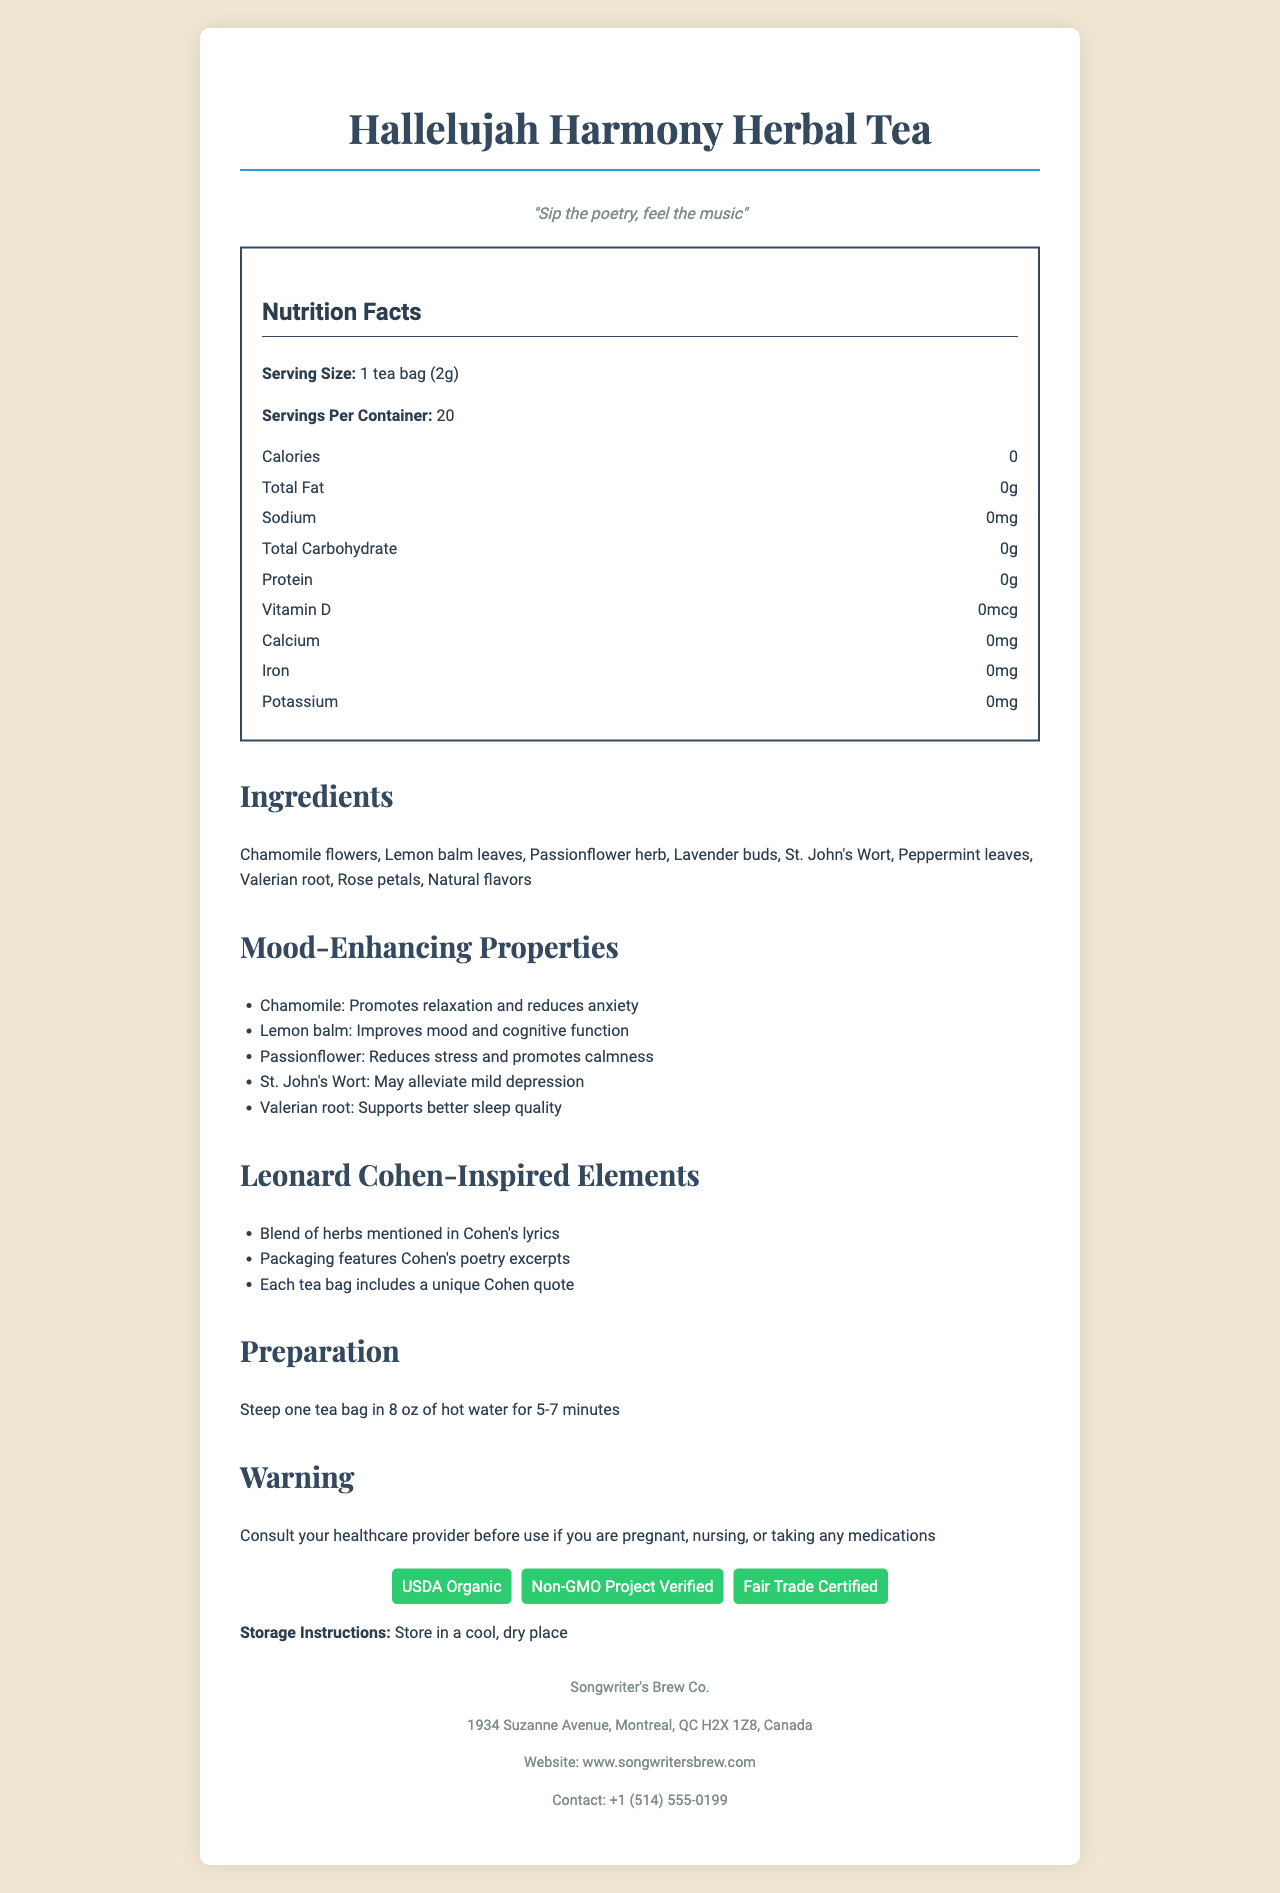What is the serving size of Hallelujah Harmony Herbal Tea? The serving size is explicitly stated as 1 tea bag (2g) in the document.
Answer: 1 tea bag (2g) How many servings are in one container of this herbal tea? The document clearly mentions that there are 20 servings per container.
Answer: 20 What are the mood-enhancing properties of St. John's Wort listed in the document? The document specifies that St. John's Wort may alleviate mild depression.
Answer: May alleviate mild depression Which ingredient in the tea promotes relaxation and reduces anxiety? Chamomile is mentioned under mood-enhancing properties as promoting relaxation and reducing anxiety.
Answer: Chamomile Is this product made with organic ingredients? The certifications section lists USDA Organic, indicating that the product is made with organic ingredients.
Answer: Yes How long should you steep the tea for optimal flavor? A. 2-4 minutes B. 5-7 minutes C. 8-10 minutes D. 10-12 minutes The preparation instructions recommend steeping one tea bag in 8 oz of hot water for 5-7 minutes.
Answer: B. 5-7 minutes Which of the following is NOT an ingredient in the Hallelujah Harmony Herbal Tea? A. Chamomile B. Ginger C. Rose petals D. Valerian root The ingredients list does not include ginger.
Answer: B. Ginger Is the tea manufactured in a facility that processes almonds? The allergen information states that the tea is manufactured in a facility that processes tree nuts, which includes almonds.
Answer: Yes Summarize the overall theme and unique aspects of the Hallelujah Harmony Herbal Tea document. The document combines nutritional facts, ingredients, mood-enhancing properties, and Leonard Cohen-inspired elements. It highlights the organic nature of the tea, manufacturing details, and certifications while providing a preparation guide and allergen information.
Answer: The Hallelujah Harmony Herbal Tea is a Leonard Cohen-inspired herbal blend with mood-enhancing properties. It includes several organic herbs like Chamomile, Lemon balm, and Valerian root, each with specific calming and stress-relieving benefits. The product is manufactured by Songwriter's Brew Co. and features unique Leonard Cohen-inspired elements such as poetry excerpts on the packaging and quotes with each tea bag. Nutrition facts show zero calories, fat, sodium, carbohydrates, and protein per serving. The tea is also certified USDA Organic, Non-GMO Project Verified, and Fair Trade Certified. Does the document mention where you can buy the tea? The document provides the company’s website and contact information but does not explicitly mention where the tea can be purchased.
Answer: Not enough information What certifications does the Hallelujah Harmony Herbal Tea have? The certifications section lists USDA Organic, Non-GMO Project Verified, and Fair Trade Certified.
Answer: USDA Organic, Non-GMO Project Verified, Fair Trade Certified 